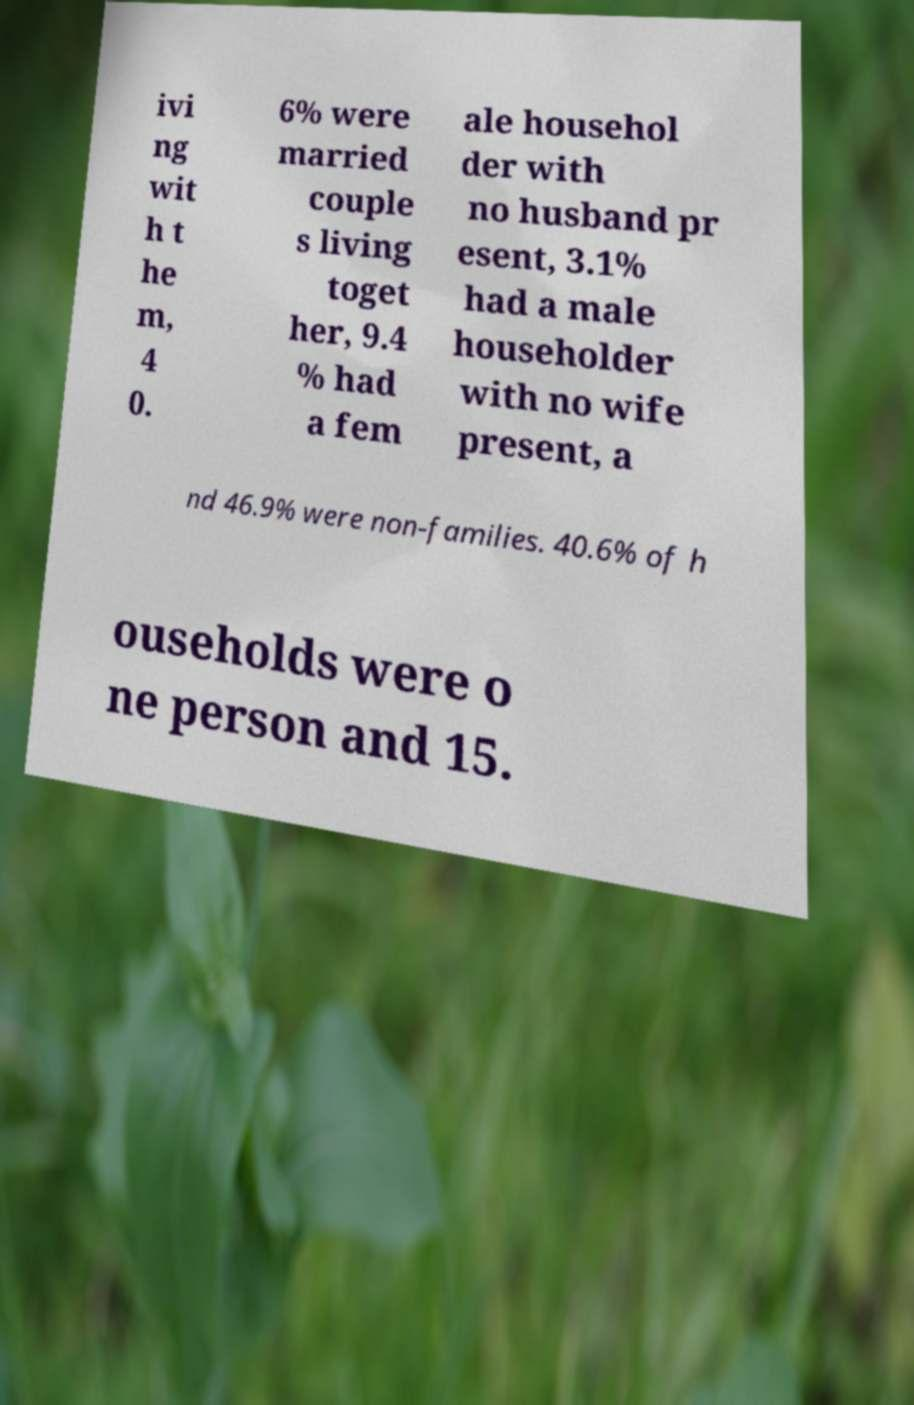Could you extract and type out the text from this image? ivi ng wit h t he m, 4 0. 6% were married couple s living toget her, 9.4 % had a fem ale househol der with no husband pr esent, 3.1% had a male householder with no wife present, a nd 46.9% were non-families. 40.6% of h ouseholds were o ne person and 15. 